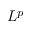Convert formula to latex. <formula><loc_0><loc_0><loc_500><loc_500>L ^ { p }</formula> 